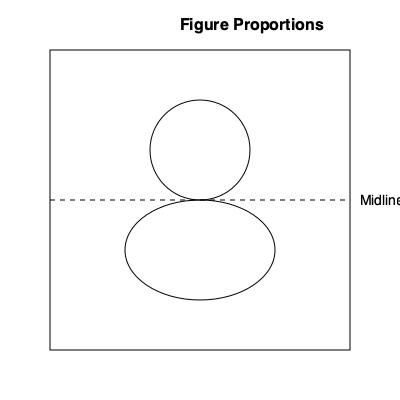In figure drawing, artists often use basic geometric shapes to establish proportions. Given the diagram above, which represents a simplified human figure using a rectangle, circle, and ellipse, what is the ratio of the head (represented by the circle) to the total height of the figure? To determine the ratio of the head to the total height of the figure, we need to follow these steps:

1. Identify the total height of the figure:
   The rectangle represents the entire figure, so its height is the total height.

2. Identify the height of the head:
   The circle represents the head.

3. Compare the head's diameter to the figure's height:
   - The circle's center is positioned at the top quarter of the rectangle.
   - The circle's diameter spans approximately 1/3 of the rectangle's height.

4. Calculate the ratio:
   - If the head is 1/3 of the total height, we can express this as a ratio of 1:3.
   - This aligns with the classic artistic proportion where the human figure is often divided into 7.5 or 8 "head lengths."

5. Simplify the ratio:
   1:3 is already in its simplest form.

This proportion, while simplified, reflects a common starting point in figure drawing. It's worth noting that real human proportions vary, and artists often adjust these ratios to express different styles or body types, challenging the notion of "ideal" proportions that may reflect privileged beauty standards.
Answer: 1:3 